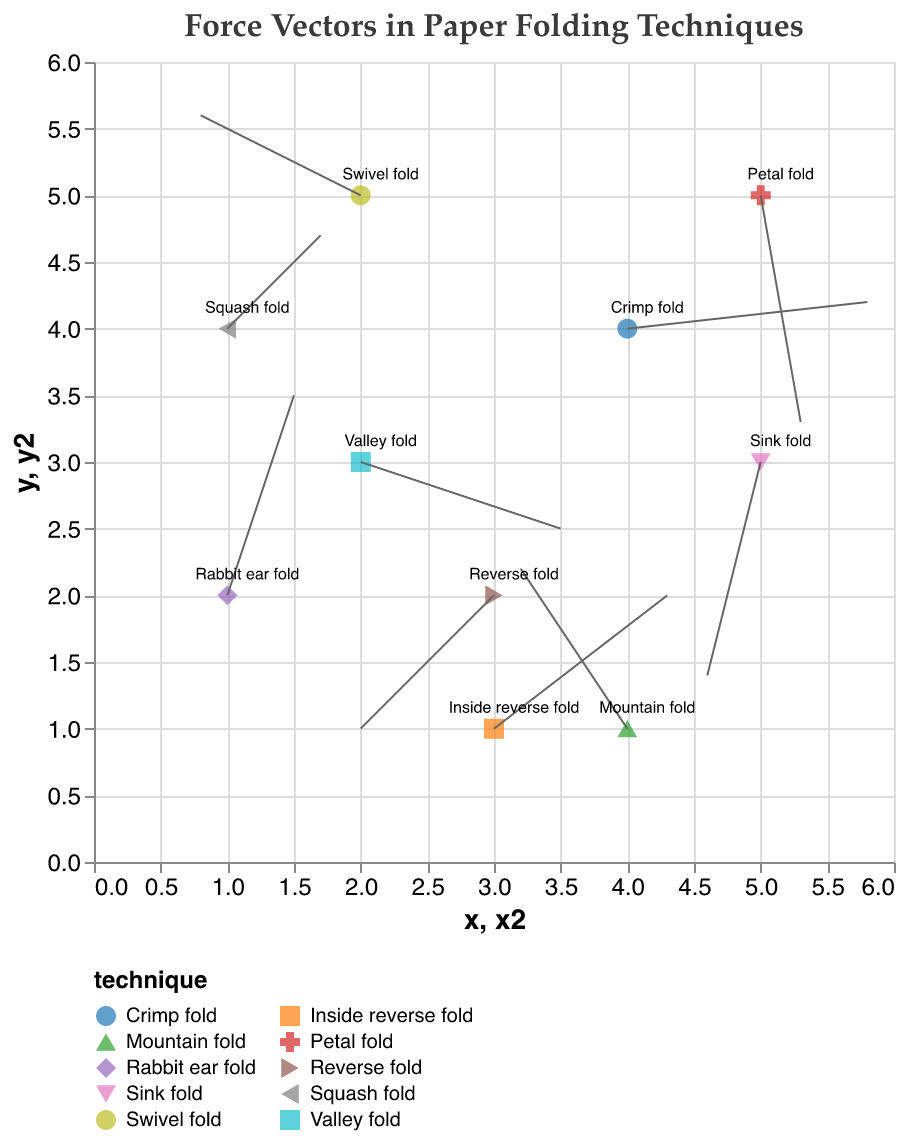What is the title of the figure? The title of the figure is displayed at the top of the plot.
Answer: "Force Vectors in Paper Folding Techniques" What are the ranges for the x and y axes? Both the x and y axes range from 0 to 6, as can be observed from the scales provided in the axis labels.
Answer: 0 to 6 How many paper folding techniques are shown in the plot? By looking at the distinct colors and legend entries, there are 10 paper folding techniques shown.
Answer: 10 Which paper folding technique has the highest magnitude vector? The vector magnitudes are indicated in the tooltip, and the "Crimp fold" has the highest magnitude of 1.81.
Answer: Crimp fold What is the y-component direction of the force vector for the "Valley fold"? The y-component for "Valley fold" has a value of -0.5, indicating it is directed downward.
Answer: Downward How do the magnitudes of the "Valley fold" and "Rabbit ear fold" compare? Both "Valley fold" and "Rabbit ear fold" have the same magnitude of 1.58, as seen in the tooltip.
Answer: Equal Which technique exhibits the smallest force vector magnitude? The "Squash fold" has the smallest magnitude vector of 0.99 as indicated by the tooltip.
Answer: Squash fold What is the resulting position of the arrow endpoint for the "Petal fold"? The starting point is at (5, 5), and the vector length in x and y directions are 0.3 and -1.7, respectively, so the endpoint is (5+0.3, 5-1.7) = (5.3, 3.3).
Answer: (5.3, 3.3) Which folding technique has the vector closest to being horizontal, and why? The "Crimp fold" has a vector (1.8, 0.2) where the y-component is very small compared to the x-component, making it nearly horizontal.
Answer: Crimp fold Do any techniques have vectors pointing in the exact opposite directions? To determine this, opposites must have their u and v components negated. "Petal fold" (0.3, -1.7) and "Sink fold" (-0.4, -1.6) do not match; no pairs match this exactly.
Answer: No 